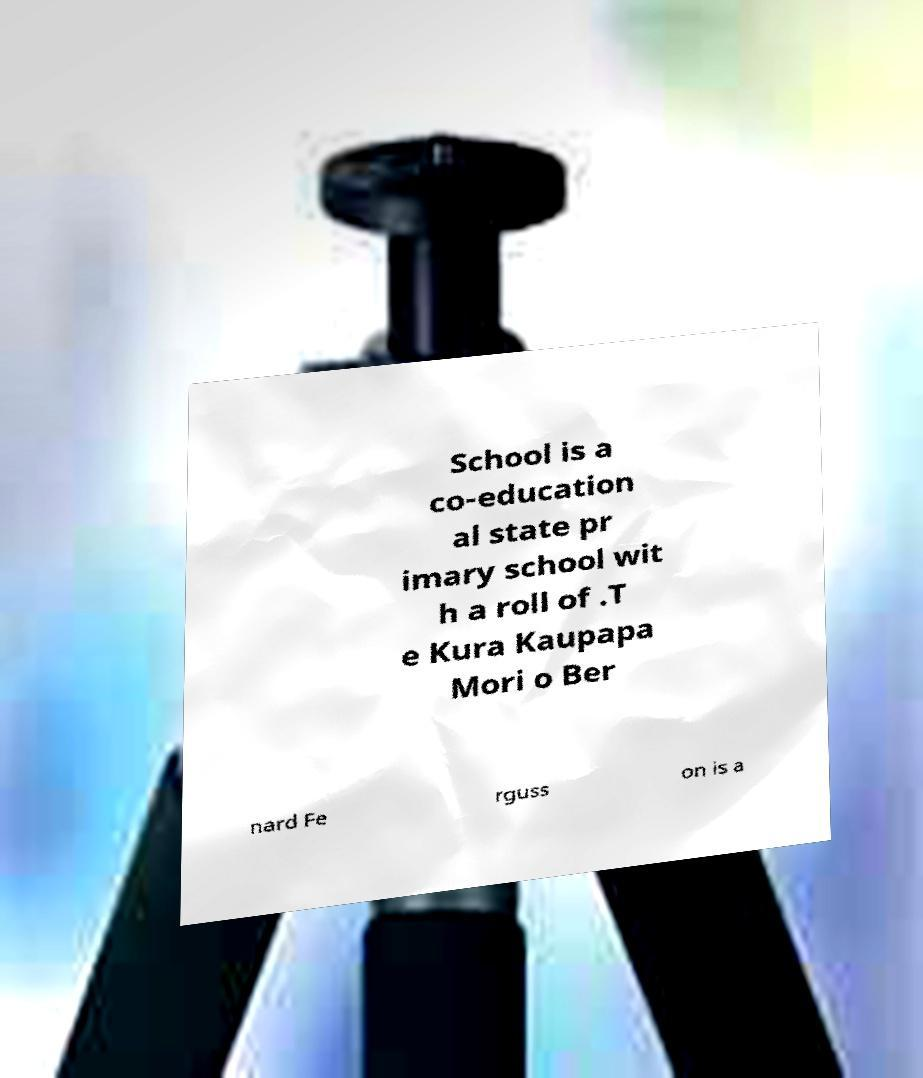There's text embedded in this image that I need extracted. Can you transcribe it verbatim? School is a co-education al state pr imary school wit h a roll of .T e Kura Kaupapa Mori o Ber nard Fe rguss on is a 